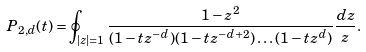<formula> <loc_0><loc_0><loc_500><loc_500>P _ { 2 , d } ( t ) = \oint _ { | z | = 1 } \frac { 1 - z ^ { 2 } } { ( 1 - t z ^ { - d } ) ( 1 - t z ^ { - d + 2 } ) \dots ( 1 - t z ^ { d } ) } \frac { d z } { z } .</formula> 